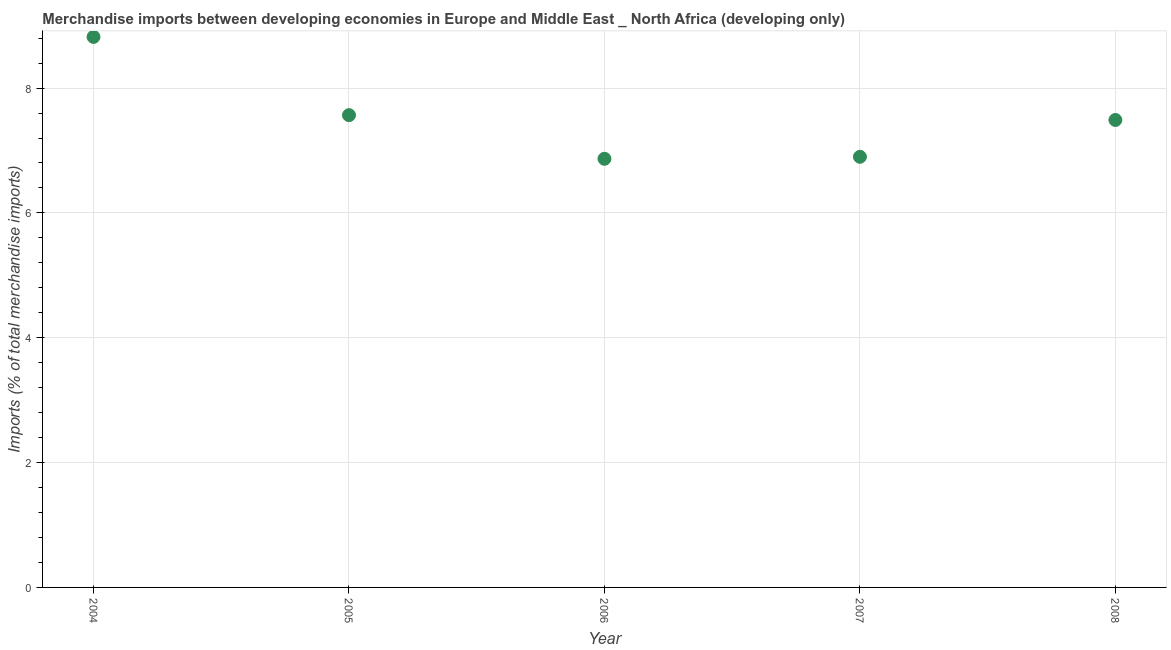What is the merchandise imports in 2005?
Keep it short and to the point. 7.57. Across all years, what is the maximum merchandise imports?
Offer a terse response. 8.82. Across all years, what is the minimum merchandise imports?
Provide a short and direct response. 6.87. What is the sum of the merchandise imports?
Your response must be concise. 37.64. What is the difference between the merchandise imports in 2004 and 2008?
Your response must be concise. 1.33. What is the average merchandise imports per year?
Give a very brief answer. 7.53. What is the median merchandise imports?
Provide a short and direct response. 7.49. In how many years, is the merchandise imports greater than 4 %?
Offer a terse response. 5. Do a majority of the years between 2005 and 2007 (inclusive) have merchandise imports greater than 2 %?
Your answer should be compact. Yes. What is the ratio of the merchandise imports in 2005 to that in 2006?
Offer a very short reply. 1.1. Is the merchandise imports in 2006 less than that in 2008?
Your answer should be compact. Yes. What is the difference between the highest and the second highest merchandise imports?
Ensure brevity in your answer.  1.25. Is the sum of the merchandise imports in 2004 and 2008 greater than the maximum merchandise imports across all years?
Offer a terse response. Yes. What is the difference between the highest and the lowest merchandise imports?
Ensure brevity in your answer.  1.95. In how many years, is the merchandise imports greater than the average merchandise imports taken over all years?
Give a very brief answer. 2. Does the merchandise imports monotonically increase over the years?
Give a very brief answer. No. How many years are there in the graph?
Provide a succinct answer. 5. What is the difference between two consecutive major ticks on the Y-axis?
Your answer should be very brief. 2. Are the values on the major ticks of Y-axis written in scientific E-notation?
Your response must be concise. No. What is the title of the graph?
Ensure brevity in your answer.  Merchandise imports between developing economies in Europe and Middle East _ North Africa (developing only). What is the label or title of the X-axis?
Provide a succinct answer. Year. What is the label or title of the Y-axis?
Ensure brevity in your answer.  Imports (% of total merchandise imports). What is the Imports (% of total merchandise imports) in 2004?
Make the answer very short. 8.82. What is the Imports (% of total merchandise imports) in 2005?
Provide a succinct answer. 7.57. What is the Imports (% of total merchandise imports) in 2006?
Offer a terse response. 6.87. What is the Imports (% of total merchandise imports) in 2007?
Give a very brief answer. 6.9. What is the Imports (% of total merchandise imports) in 2008?
Ensure brevity in your answer.  7.49. What is the difference between the Imports (% of total merchandise imports) in 2004 and 2005?
Make the answer very short. 1.25. What is the difference between the Imports (% of total merchandise imports) in 2004 and 2006?
Your answer should be very brief. 1.95. What is the difference between the Imports (% of total merchandise imports) in 2004 and 2007?
Ensure brevity in your answer.  1.92. What is the difference between the Imports (% of total merchandise imports) in 2004 and 2008?
Offer a very short reply. 1.33. What is the difference between the Imports (% of total merchandise imports) in 2005 and 2006?
Keep it short and to the point. 0.7. What is the difference between the Imports (% of total merchandise imports) in 2005 and 2007?
Your response must be concise. 0.67. What is the difference between the Imports (% of total merchandise imports) in 2005 and 2008?
Offer a terse response. 0.08. What is the difference between the Imports (% of total merchandise imports) in 2006 and 2007?
Your response must be concise. -0.03. What is the difference between the Imports (% of total merchandise imports) in 2006 and 2008?
Your answer should be compact. -0.62. What is the difference between the Imports (% of total merchandise imports) in 2007 and 2008?
Your response must be concise. -0.59. What is the ratio of the Imports (% of total merchandise imports) in 2004 to that in 2005?
Give a very brief answer. 1.17. What is the ratio of the Imports (% of total merchandise imports) in 2004 to that in 2006?
Your answer should be compact. 1.28. What is the ratio of the Imports (% of total merchandise imports) in 2004 to that in 2007?
Offer a very short reply. 1.28. What is the ratio of the Imports (% of total merchandise imports) in 2004 to that in 2008?
Offer a terse response. 1.18. What is the ratio of the Imports (% of total merchandise imports) in 2005 to that in 2006?
Your answer should be compact. 1.1. What is the ratio of the Imports (% of total merchandise imports) in 2005 to that in 2007?
Your response must be concise. 1.1. What is the ratio of the Imports (% of total merchandise imports) in 2006 to that in 2007?
Provide a succinct answer. 0.99. What is the ratio of the Imports (% of total merchandise imports) in 2006 to that in 2008?
Give a very brief answer. 0.92. What is the ratio of the Imports (% of total merchandise imports) in 2007 to that in 2008?
Your response must be concise. 0.92. 